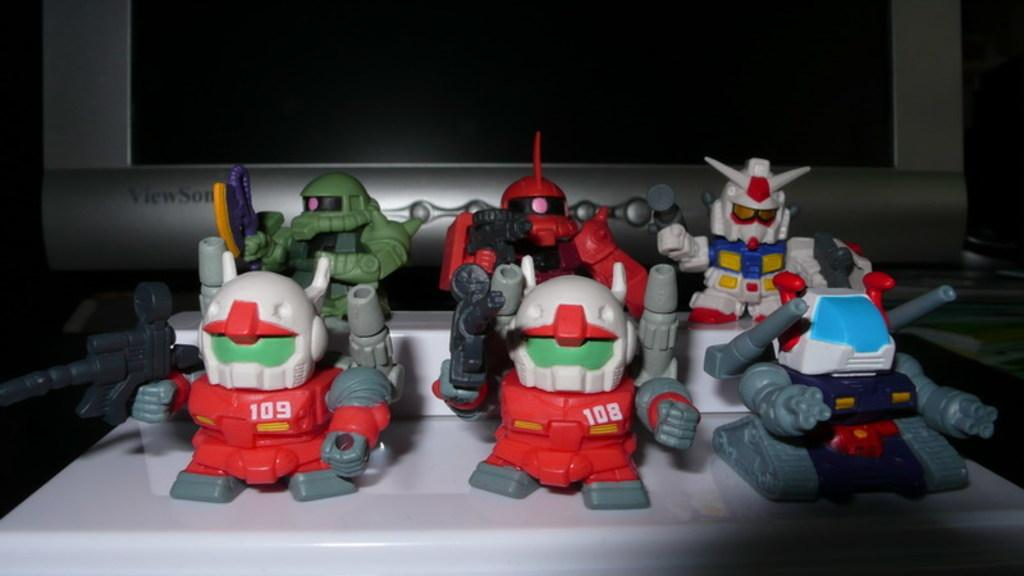What can be found on the object in the image? There are toys on an object in the image. What electronic device is present in the image? There is a monitor in the image. How would you describe the overall lighting in the image? The background of the image is dark. Can you see any sparks coming from the toys in the image? There are no sparks present in the image; the toys are simply placed on an object. How does the monitor pull the toys towards it in the image? The monitor does not pull the toys towards it in the image; the toys are stationary on the object. 